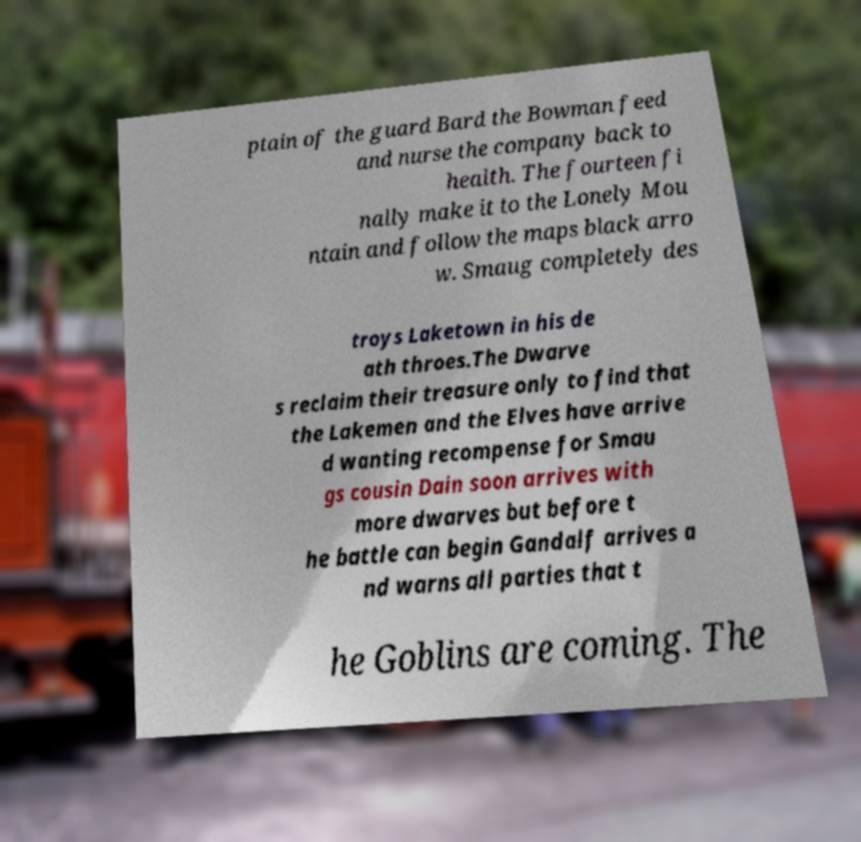For documentation purposes, I need the text within this image transcribed. Could you provide that? ptain of the guard Bard the Bowman feed and nurse the company back to health. The fourteen fi nally make it to the Lonely Mou ntain and follow the maps black arro w. Smaug completely des troys Laketown in his de ath throes.The Dwarve s reclaim their treasure only to find that the Lakemen and the Elves have arrive d wanting recompense for Smau gs cousin Dain soon arrives with more dwarves but before t he battle can begin Gandalf arrives a nd warns all parties that t he Goblins are coming. The 